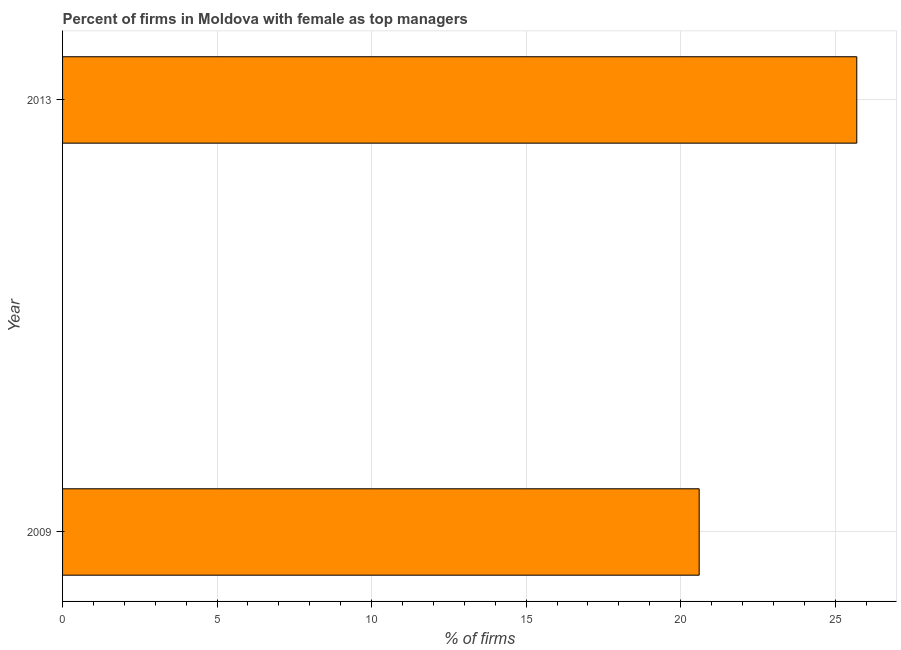Does the graph contain any zero values?
Offer a very short reply. No. What is the title of the graph?
Your response must be concise. Percent of firms in Moldova with female as top managers. What is the label or title of the X-axis?
Make the answer very short. % of firms. What is the percentage of firms with female as top manager in 2009?
Offer a very short reply. 20.6. Across all years, what is the maximum percentage of firms with female as top manager?
Give a very brief answer. 25.7. Across all years, what is the minimum percentage of firms with female as top manager?
Provide a succinct answer. 20.6. In which year was the percentage of firms with female as top manager maximum?
Provide a succinct answer. 2013. In which year was the percentage of firms with female as top manager minimum?
Give a very brief answer. 2009. What is the sum of the percentage of firms with female as top manager?
Offer a very short reply. 46.3. What is the average percentage of firms with female as top manager per year?
Provide a succinct answer. 23.15. What is the median percentage of firms with female as top manager?
Make the answer very short. 23.15. In how many years, is the percentage of firms with female as top manager greater than 25 %?
Make the answer very short. 1. What is the ratio of the percentage of firms with female as top manager in 2009 to that in 2013?
Offer a very short reply. 0.8. Are all the bars in the graph horizontal?
Make the answer very short. Yes. Are the values on the major ticks of X-axis written in scientific E-notation?
Provide a succinct answer. No. What is the % of firms in 2009?
Offer a very short reply. 20.6. What is the % of firms of 2013?
Make the answer very short. 25.7. What is the difference between the % of firms in 2009 and 2013?
Make the answer very short. -5.1. What is the ratio of the % of firms in 2009 to that in 2013?
Your answer should be compact. 0.8. 